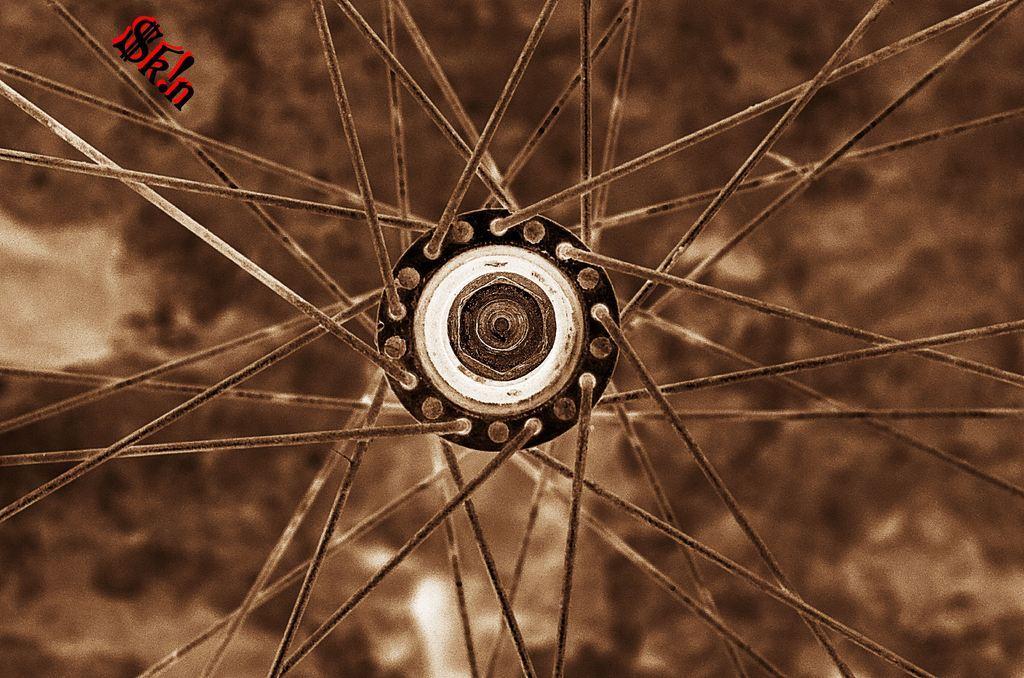Please provide a concise description of this image. This image is taken outdoors. In this image the background is a little blurred. In the middle of the image there is a wheel of a bicycle. 